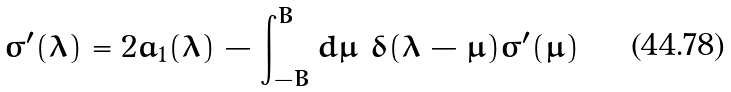<formula> <loc_0><loc_0><loc_500><loc_500>\sigma ^ { \prime } ( \lambda ) = 2 a _ { 1 } ( \lambda ) - \int _ { - B } ^ { B } d \mu \ \delta ( \lambda - \mu ) \sigma ^ { \prime } ( \mu )</formula> 